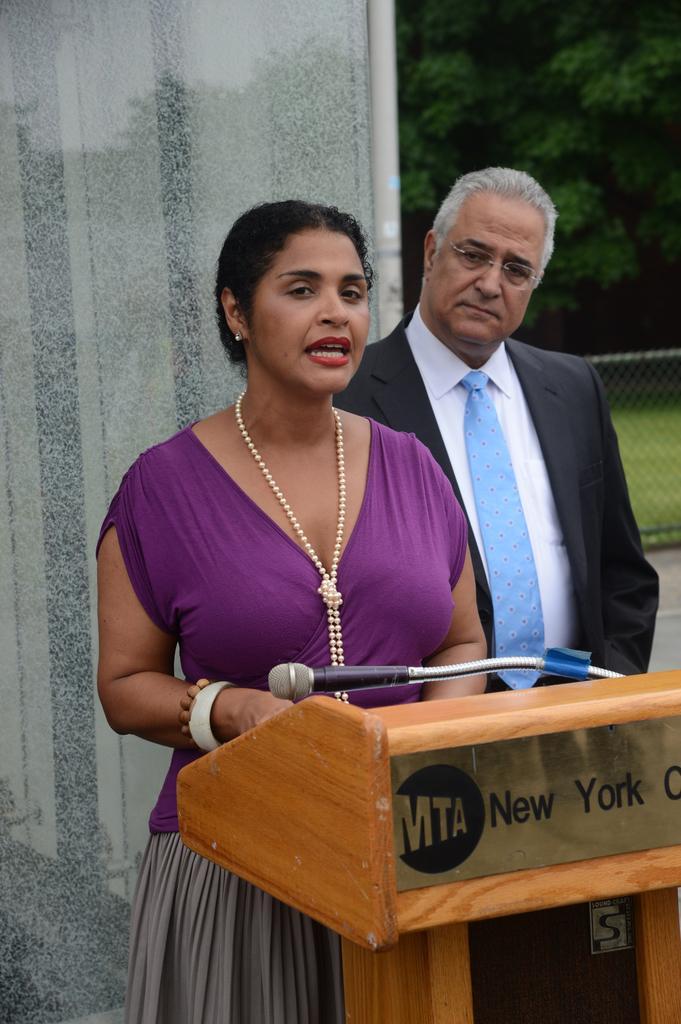Please provide a concise description of this image. In this picture we can see a man and a woman. There is a podium and a mike. In the background we can see wall, welded wire mesh, and trees. 